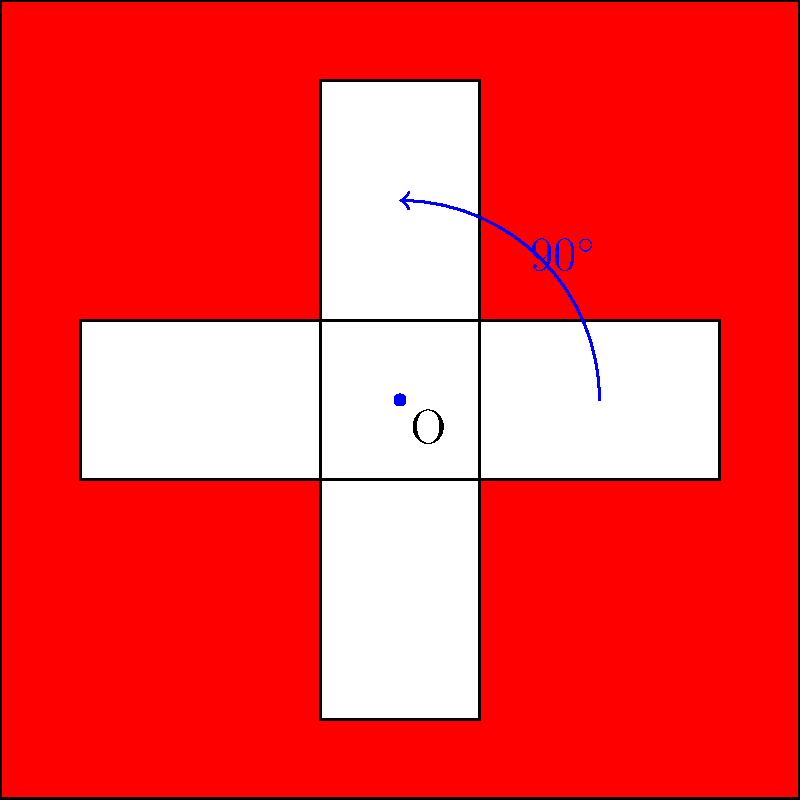In preparation for your trip to Switzerland, you're studying the Swiss flag design. If the flag is rotated $90^\circ$ clockwise around point O, which statement best describes the resulting image? Let's analyze this step-by-step:

1. The original Swiss flag design consists of a red square with a white cross in the center.

2. The point O is at the center of the flag, where the arms of the cross intersect.

3. A $90^\circ$ clockwise rotation around point O means:
   - Every point on the flag will move $90^\circ$ clockwise around O.
   - The corners of the square will rotate to new positions.
   - The arms of the cross will also rotate.

4. After rotation:
   - The red square will still be a red square, as rotation preserves shape and size.
   - The white cross will still be centered at O.
   - The vertical arm of the cross will become horizontal.
   - The horizontal arm of the cross will become vertical.

5. The key observation is that due to the symmetry of the Swiss flag design, a $90^\circ$ rotation will produce an image identical to the original flag.

6. In Swiss German, which you might encounter on your trip, you could describe this as "gliich" (meaning "same" or "identical").
Answer: The rotated flag appears identical to the original. 